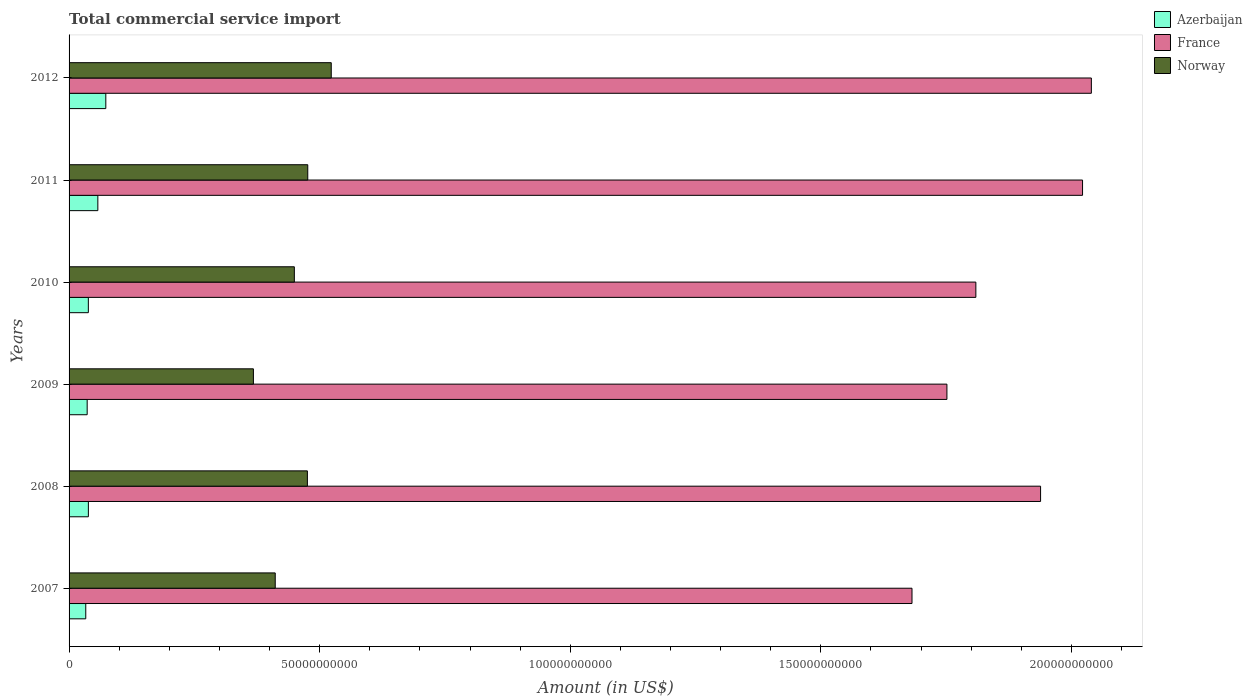How many different coloured bars are there?
Your answer should be compact. 3. Are the number of bars per tick equal to the number of legend labels?
Your response must be concise. Yes. Are the number of bars on each tick of the Y-axis equal?
Give a very brief answer. Yes. How many bars are there on the 6th tick from the bottom?
Your answer should be compact. 3. What is the label of the 4th group of bars from the top?
Provide a succinct answer. 2009. What is the total commercial service import in Azerbaijan in 2010?
Offer a terse response. 3.85e+09. Across all years, what is the maximum total commercial service import in Azerbaijan?
Offer a very short reply. 7.33e+09. Across all years, what is the minimum total commercial service import in Azerbaijan?
Your response must be concise. 3.33e+09. In which year was the total commercial service import in Norway maximum?
Offer a terse response. 2012. What is the total total commercial service import in Norway in the graph?
Offer a terse response. 2.70e+11. What is the difference between the total commercial service import in France in 2009 and that in 2010?
Your answer should be very brief. -5.77e+09. What is the difference between the total commercial service import in France in 2010 and the total commercial service import in Norway in 2012?
Provide a short and direct response. 1.29e+11. What is the average total commercial service import in Norway per year?
Provide a short and direct response. 4.51e+1. In the year 2007, what is the difference between the total commercial service import in France and total commercial service import in Norway?
Offer a very short reply. 1.27e+11. In how many years, is the total commercial service import in Azerbaijan greater than 110000000000 US$?
Offer a very short reply. 0. What is the ratio of the total commercial service import in France in 2008 to that in 2012?
Offer a very short reply. 0.95. Is the difference between the total commercial service import in France in 2009 and 2010 greater than the difference between the total commercial service import in Norway in 2009 and 2010?
Give a very brief answer. Yes. What is the difference between the highest and the second highest total commercial service import in Norway?
Offer a very short reply. 4.69e+09. What is the difference between the highest and the lowest total commercial service import in France?
Ensure brevity in your answer.  3.58e+1. Is the sum of the total commercial service import in Azerbaijan in 2010 and 2012 greater than the maximum total commercial service import in Norway across all years?
Give a very brief answer. No. What does the 1st bar from the bottom in 2008 represents?
Your response must be concise. Azerbaijan. How many bars are there?
Ensure brevity in your answer.  18. How many years are there in the graph?
Make the answer very short. 6. What is the difference between two consecutive major ticks on the X-axis?
Ensure brevity in your answer.  5.00e+1. Are the values on the major ticks of X-axis written in scientific E-notation?
Keep it short and to the point. No. Does the graph contain grids?
Offer a very short reply. No. Where does the legend appear in the graph?
Make the answer very short. Top right. How are the legend labels stacked?
Give a very brief answer. Vertical. What is the title of the graph?
Provide a short and direct response. Total commercial service import. Does "Philippines" appear as one of the legend labels in the graph?
Offer a very short reply. No. What is the label or title of the Y-axis?
Offer a terse response. Years. What is the Amount (in US$) in Azerbaijan in 2007?
Ensure brevity in your answer.  3.33e+09. What is the Amount (in US$) of France in 2007?
Offer a terse response. 1.68e+11. What is the Amount (in US$) in Norway in 2007?
Make the answer very short. 4.11e+1. What is the Amount (in US$) in Azerbaijan in 2008?
Your response must be concise. 3.85e+09. What is the Amount (in US$) in France in 2008?
Keep it short and to the point. 1.94e+11. What is the Amount (in US$) in Norway in 2008?
Your answer should be very brief. 4.76e+1. What is the Amount (in US$) in Azerbaijan in 2009?
Offer a terse response. 3.61e+09. What is the Amount (in US$) in France in 2009?
Offer a terse response. 1.75e+11. What is the Amount (in US$) in Norway in 2009?
Give a very brief answer. 3.68e+1. What is the Amount (in US$) of Azerbaijan in 2010?
Give a very brief answer. 3.85e+09. What is the Amount (in US$) in France in 2010?
Your answer should be compact. 1.81e+11. What is the Amount (in US$) of Norway in 2010?
Offer a terse response. 4.49e+1. What is the Amount (in US$) of Azerbaijan in 2011?
Ensure brevity in your answer.  5.74e+09. What is the Amount (in US$) in France in 2011?
Offer a very short reply. 2.02e+11. What is the Amount (in US$) of Norway in 2011?
Keep it short and to the point. 4.76e+1. What is the Amount (in US$) of Azerbaijan in 2012?
Your response must be concise. 7.33e+09. What is the Amount (in US$) in France in 2012?
Ensure brevity in your answer.  2.04e+11. What is the Amount (in US$) in Norway in 2012?
Your answer should be compact. 5.23e+1. Across all years, what is the maximum Amount (in US$) of Azerbaijan?
Your answer should be very brief. 7.33e+09. Across all years, what is the maximum Amount (in US$) in France?
Offer a very short reply. 2.04e+11. Across all years, what is the maximum Amount (in US$) in Norway?
Give a very brief answer. 5.23e+1. Across all years, what is the minimum Amount (in US$) in Azerbaijan?
Provide a short and direct response. 3.33e+09. Across all years, what is the minimum Amount (in US$) in France?
Make the answer very short. 1.68e+11. Across all years, what is the minimum Amount (in US$) of Norway?
Offer a very short reply. 3.68e+1. What is the total Amount (in US$) of Azerbaijan in the graph?
Provide a short and direct response. 2.77e+1. What is the total Amount (in US$) of France in the graph?
Provide a succinct answer. 1.12e+12. What is the total Amount (in US$) in Norway in the graph?
Provide a short and direct response. 2.70e+11. What is the difference between the Amount (in US$) of Azerbaijan in 2007 and that in 2008?
Ensure brevity in your answer.  -5.21e+08. What is the difference between the Amount (in US$) of France in 2007 and that in 2008?
Ensure brevity in your answer.  -2.57e+1. What is the difference between the Amount (in US$) in Norway in 2007 and that in 2008?
Give a very brief answer. -6.42e+09. What is the difference between the Amount (in US$) of Azerbaijan in 2007 and that in 2009?
Ensure brevity in your answer.  -2.82e+08. What is the difference between the Amount (in US$) in France in 2007 and that in 2009?
Your answer should be compact. -6.97e+09. What is the difference between the Amount (in US$) in Norway in 2007 and that in 2009?
Your answer should be compact. 4.35e+09. What is the difference between the Amount (in US$) of Azerbaijan in 2007 and that in 2010?
Ensure brevity in your answer.  -5.14e+08. What is the difference between the Amount (in US$) in France in 2007 and that in 2010?
Your answer should be very brief. -1.27e+1. What is the difference between the Amount (in US$) of Norway in 2007 and that in 2010?
Make the answer very short. -3.82e+09. What is the difference between the Amount (in US$) of Azerbaijan in 2007 and that in 2011?
Keep it short and to the point. -2.41e+09. What is the difference between the Amount (in US$) in France in 2007 and that in 2011?
Your answer should be compact. -3.40e+1. What is the difference between the Amount (in US$) of Norway in 2007 and that in 2011?
Offer a terse response. -6.49e+09. What is the difference between the Amount (in US$) of Azerbaijan in 2007 and that in 2012?
Offer a very short reply. -4.00e+09. What is the difference between the Amount (in US$) of France in 2007 and that in 2012?
Your response must be concise. -3.58e+1. What is the difference between the Amount (in US$) of Norway in 2007 and that in 2012?
Provide a short and direct response. -1.12e+1. What is the difference between the Amount (in US$) in Azerbaijan in 2008 and that in 2009?
Your answer should be very brief. 2.40e+08. What is the difference between the Amount (in US$) in France in 2008 and that in 2009?
Make the answer very short. 1.87e+1. What is the difference between the Amount (in US$) in Norway in 2008 and that in 2009?
Provide a succinct answer. 1.08e+1. What is the difference between the Amount (in US$) in Azerbaijan in 2008 and that in 2010?
Your answer should be compact. 6.83e+06. What is the difference between the Amount (in US$) in France in 2008 and that in 2010?
Offer a terse response. 1.29e+1. What is the difference between the Amount (in US$) of Norway in 2008 and that in 2010?
Provide a short and direct response. 2.60e+09. What is the difference between the Amount (in US$) in Azerbaijan in 2008 and that in 2011?
Ensure brevity in your answer.  -1.89e+09. What is the difference between the Amount (in US$) in France in 2008 and that in 2011?
Give a very brief answer. -8.37e+09. What is the difference between the Amount (in US$) in Norway in 2008 and that in 2011?
Offer a very short reply. -7.38e+07. What is the difference between the Amount (in US$) in Azerbaijan in 2008 and that in 2012?
Your answer should be very brief. -3.48e+09. What is the difference between the Amount (in US$) in France in 2008 and that in 2012?
Offer a terse response. -1.01e+1. What is the difference between the Amount (in US$) of Norway in 2008 and that in 2012?
Your answer should be compact. -4.76e+09. What is the difference between the Amount (in US$) in Azerbaijan in 2009 and that in 2010?
Make the answer very short. -2.33e+08. What is the difference between the Amount (in US$) in France in 2009 and that in 2010?
Offer a very short reply. -5.77e+09. What is the difference between the Amount (in US$) of Norway in 2009 and that in 2010?
Your answer should be compact. -8.17e+09. What is the difference between the Amount (in US$) of Azerbaijan in 2009 and that in 2011?
Give a very brief answer. -2.13e+09. What is the difference between the Amount (in US$) in France in 2009 and that in 2011?
Offer a very short reply. -2.71e+1. What is the difference between the Amount (in US$) of Norway in 2009 and that in 2011?
Your answer should be compact. -1.08e+1. What is the difference between the Amount (in US$) in Azerbaijan in 2009 and that in 2012?
Your response must be concise. -3.72e+09. What is the difference between the Amount (in US$) in France in 2009 and that in 2012?
Keep it short and to the point. -2.88e+1. What is the difference between the Amount (in US$) of Norway in 2009 and that in 2012?
Your answer should be very brief. -1.55e+1. What is the difference between the Amount (in US$) of Azerbaijan in 2010 and that in 2011?
Offer a very short reply. -1.90e+09. What is the difference between the Amount (in US$) of France in 2010 and that in 2011?
Provide a short and direct response. -2.13e+1. What is the difference between the Amount (in US$) of Norway in 2010 and that in 2011?
Ensure brevity in your answer.  -2.68e+09. What is the difference between the Amount (in US$) in Azerbaijan in 2010 and that in 2012?
Your answer should be compact. -3.48e+09. What is the difference between the Amount (in US$) in France in 2010 and that in 2012?
Offer a terse response. -2.30e+1. What is the difference between the Amount (in US$) in Norway in 2010 and that in 2012?
Keep it short and to the point. -7.36e+09. What is the difference between the Amount (in US$) in Azerbaijan in 2011 and that in 2012?
Offer a terse response. -1.59e+09. What is the difference between the Amount (in US$) in France in 2011 and that in 2012?
Ensure brevity in your answer.  -1.76e+09. What is the difference between the Amount (in US$) in Norway in 2011 and that in 2012?
Offer a terse response. -4.69e+09. What is the difference between the Amount (in US$) in Azerbaijan in 2007 and the Amount (in US$) in France in 2008?
Make the answer very short. -1.91e+11. What is the difference between the Amount (in US$) of Azerbaijan in 2007 and the Amount (in US$) of Norway in 2008?
Ensure brevity in your answer.  -4.42e+1. What is the difference between the Amount (in US$) in France in 2007 and the Amount (in US$) in Norway in 2008?
Your answer should be very brief. 1.21e+11. What is the difference between the Amount (in US$) in Azerbaijan in 2007 and the Amount (in US$) in France in 2009?
Give a very brief answer. -1.72e+11. What is the difference between the Amount (in US$) in Azerbaijan in 2007 and the Amount (in US$) in Norway in 2009?
Offer a very short reply. -3.34e+1. What is the difference between the Amount (in US$) in France in 2007 and the Amount (in US$) in Norway in 2009?
Make the answer very short. 1.31e+11. What is the difference between the Amount (in US$) in Azerbaijan in 2007 and the Amount (in US$) in France in 2010?
Keep it short and to the point. -1.78e+11. What is the difference between the Amount (in US$) of Azerbaijan in 2007 and the Amount (in US$) of Norway in 2010?
Provide a short and direct response. -4.16e+1. What is the difference between the Amount (in US$) of France in 2007 and the Amount (in US$) of Norway in 2010?
Your answer should be very brief. 1.23e+11. What is the difference between the Amount (in US$) in Azerbaijan in 2007 and the Amount (in US$) in France in 2011?
Provide a succinct answer. -1.99e+11. What is the difference between the Amount (in US$) of Azerbaijan in 2007 and the Amount (in US$) of Norway in 2011?
Ensure brevity in your answer.  -4.43e+1. What is the difference between the Amount (in US$) of France in 2007 and the Amount (in US$) of Norway in 2011?
Offer a terse response. 1.21e+11. What is the difference between the Amount (in US$) in Azerbaijan in 2007 and the Amount (in US$) in France in 2012?
Provide a short and direct response. -2.01e+11. What is the difference between the Amount (in US$) in Azerbaijan in 2007 and the Amount (in US$) in Norway in 2012?
Offer a terse response. -4.90e+1. What is the difference between the Amount (in US$) in France in 2007 and the Amount (in US$) in Norway in 2012?
Offer a very short reply. 1.16e+11. What is the difference between the Amount (in US$) in Azerbaijan in 2008 and the Amount (in US$) in France in 2009?
Your answer should be very brief. -1.71e+11. What is the difference between the Amount (in US$) in Azerbaijan in 2008 and the Amount (in US$) in Norway in 2009?
Offer a very short reply. -3.29e+1. What is the difference between the Amount (in US$) in France in 2008 and the Amount (in US$) in Norway in 2009?
Keep it short and to the point. 1.57e+11. What is the difference between the Amount (in US$) of Azerbaijan in 2008 and the Amount (in US$) of France in 2010?
Your response must be concise. -1.77e+11. What is the difference between the Amount (in US$) of Azerbaijan in 2008 and the Amount (in US$) of Norway in 2010?
Offer a very short reply. -4.11e+1. What is the difference between the Amount (in US$) of France in 2008 and the Amount (in US$) of Norway in 2010?
Offer a very short reply. 1.49e+11. What is the difference between the Amount (in US$) in Azerbaijan in 2008 and the Amount (in US$) in France in 2011?
Make the answer very short. -1.98e+11. What is the difference between the Amount (in US$) of Azerbaijan in 2008 and the Amount (in US$) of Norway in 2011?
Your response must be concise. -4.38e+1. What is the difference between the Amount (in US$) in France in 2008 and the Amount (in US$) in Norway in 2011?
Your answer should be very brief. 1.46e+11. What is the difference between the Amount (in US$) in Azerbaijan in 2008 and the Amount (in US$) in France in 2012?
Ensure brevity in your answer.  -2.00e+11. What is the difference between the Amount (in US$) of Azerbaijan in 2008 and the Amount (in US$) of Norway in 2012?
Ensure brevity in your answer.  -4.85e+1. What is the difference between the Amount (in US$) of France in 2008 and the Amount (in US$) of Norway in 2012?
Keep it short and to the point. 1.42e+11. What is the difference between the Amount (in US$) in Azerbaijan in 2009 and the Amount (in US$) in France in 2010?
Your response must be concise. -1.77e+11. What is the difference between the Amount (in US$) in Azerbaijan in 2009 and the Amount (in US$) in Norway in 2010?
Keep it short and to the point. -4.13e+1. What is the difference between the Amount (in US$) of France in 2009 and the Amount (in US$) of Norway in 2010?
Your response must be concise. 1.30e+11. What is the difference between the Amount (in US$) in Azerbaijan in 2009 and the Amount (in US$) in France in 2011?
Make the answer very short. -1.99e+11. What is the difference between the Amount (in US$) of Azerbaijan in 2009 and the Amount (in US$) of Norway in 2011?
Your response must be concise. -4.40e+1. What is the difference between the Amount (in US$) of France in 2009 and the Amount (in US$) of Norway in 2011?
Your answer should be very brief. 1.28e+11. What is the difference between the Amount (in US$) in Azerbaijan in 2009 and the Amount (in US$) in France in 2012?
Your answer should be compact. -2.00e+11. What is the difference between the Amount (in US$) in Azerbaijan in 2009 and the Amount (in US$) in Norway in 2012?
Keep it short and to the point. -4.87e+1. What is the difference between the Amount (in US$) of France in 2009 and the Amount (in US$) of Norway in 2012?
Make the answer very short. 1.23e+11. What is the difference between the Amount (in US$) of Azerbaijan in 2010 and the Amount (in US$) of France in 2011?
Ensure brevity in your answer.  -1.98e+11. What is the difference between the Amount (in US$) in Azerbaijan in 2010 and the Amount (in US$) in Norway in 2011?
Give a very brief answer. -4.38e+1. What is the difference between the Amount (in US$) in France in 2010 and the Amount (in US$) in Norway in 2011?
Provide a succinct answer. 1.33e+11. What is the difference between the Amount (in US$) of Azerbaijan in 2010 and the Amount (in US$) of France in 2012?
Provide a short and direct response. -2.00e+11. What is the difference between the Amount (in US$) of Azerbaijan in 2010 and the Amount (in US$) of Norway in 2012?
Keep it short and to the point. -4.85e+1. What is the difference between the Amount (in US$) of France in 2010 and the Amount (in US$) of Norway in 2012?
Give a very brief answer. 1.29e+11. What is the difference between the Amount (in US$) in Azerbaijan in 2011 and the Amount (in US$) in France in 2012?
Provide a short and direct response. -1.98e+11. What is the difference between the Amount (in US$) of Azerbaijan in 2011 and the Amount (in US$) of Norway in 2012?
Keep it short and to the point. -4.66e+1. What is the difference between the Amount (in US$) in France in 2011 and the Amount (in US$) in Norway in 2012?
Your answer should be compact. 1.50e+11. What is the average Amount (in US$) in Azerbaijan per year?
Keep it short and to the point. 4.62e+09. What is the average Amount (in US$) in France per year?
Your response must be concise. 1.87e+11. What is the average Amount (in US$) in Norway per year?
Give a very brief answer. 4.51e+1. In the year 2007, what is the difference between the Amount (in US$) of Azerbaijan and Amount (in US$) of France?
Keep it short and to the point. -1.65e+11. In the year 2007, what is the difference between the Amount (in US$) of Azerbaijan and Amount (in US$) of Norway?
Provide a succinct answer. -3.78e+1. In the year 2007, what is the difference between the Amount (in US$) of France and Amount (in US$) of Norway?
Give a very brief answer. 1.27e+11. In the year 2008, what is the difference between the Amount (in US$) in Azerbaijan and Amount (in US$) in France?
Your response must be concise. -1.90e+11. In the year 2008, what is the difference between the Amount (in US$) of Azerbaijan and Amount (in US$) of Norway?
Keep it short and to the point. -4.37e+1. In the year 2008, what is the difference between the Amount (in US$) in France and Amount (in US$) in Norway?
Keep it short and to the point. 1.46e+11. In the year 2009, what is the difference between the Amount (in US$) in Azerbaijan and Amount (in US$) in France?
Offer a terse response. -1.72e+11. In the year 2009, what is the difference between the Amount (in US$) of Azerbaijan and Amount (in US$) of Norway?
Make the answer very short. -3.32e+1. In the year 2009, what is the difference between the Amount (in US$) of France and Amount (in US$) of Norway?
Your answer should be very brief. 1.38e+11. In the year 2010, what is the difference between the Amount (in US$) in Azerbaijan and Amount (in US$) in France?
Ensure brevity in your answer.  -1.77e+11. In the year 2010, what is the difference between the Amount (in US$) of Azerbaijan and Amount (in US$) of Norway?
Provide a succinct answer. -4.11e+1. In the year 2010, what is the difference between the Amount (in US$) of France and Amount (in US$) of Norway?
Your response must be concise. 1.36e+11. In the year 2011, what is the difference between the Amount (in US$) in Azerbaijan and Amount (in US$) in France?
Make the answer very short. -1.96e+11. In the year 2011, what is the difference between the Amount (in US$) of Azerbaijan and Amount (in US$) of Norway?
Provide a short and direct response. -4.19e+1. In the year 2011, what is the difference between the Amount (in US$) of France and Amount (in US$) of Norway?
Your answer should be compact. 1.55e+11. In the year 2012, what is the difference between the Amount (in US$) in Azerbaijan and Amount (in US$) in France?
Provide a short and direct response. -1.97e+11. In the year 2012, what is the difference between the Amount (in US$) of Azerbaijan and Amount (in US$) of Norway?
Provide a succinct answer. -4.50e+1. In the year 2012, what is the difference between the Amount (in US$) of France and Amount (in US$) of Norway?
Provide a succinct answer. 1.52e+11. What is the ratio of the Amount (in US$) of Azerbaijan in 2007 to that in 2008?
Make the answer very short. 0.86. What is the ratio of the Amount (in US$) of France in 2007 to that in 2008?
Offer a very short reply. 0.87. What is the ratio of the Amount (in US$) in Norway in 2007 to that in 2008?
Your answer should be compact. 0.86. What is the ratio of the Amount (in US$) of Azerbaijan in 2007 to that in 2009?
Provide a succinct answer. 0.92. What is the ratio of the Amount (in US$) in France in 2007 to that in 2009?
Provide a succinct answer. 0.96. What is the ratio of the Amount (in US$) of Norway in 2007 to that in 2009?
Provide a short and direct response. 1.12. What is the ratio of the Amount (in US$) in Azerbaijan in 2007 to that in 2010?
Provide a short and direct response. 0.87. What is the ratio of the Amount (in US$) in France in 2007 to that in 2010?
Give a very brief answer. 0.93. What is the ratio of the Amount (in US$) in Norway in 2007 to that in 2010?
Offer a terse response. 0.92. What is the ratio of the Amount (in US$) in Azerbaijan in 2007 to that in 2011?
Offer a very short reply. 0.58. What is the ratio of the Amount (in US$) of France in 2007 to that in 2011?
Offer a terse response. 0.83. What is the ratio of the Amount (in US$) in Norway in 2007 to that in 2011?
Give a very brief answer. 0.86. What is the ratio of the Amount (in US$) in Azerbaijan in 2007 to that in 2012?
Offer a very short reply. 0.45. What is the ratio of the Amount (in US$) in France in 2007 to that in 2012?
Your response must be concise. 0.82. What is the ratio of the Amount (in US$) of Norway in 2007 to that in 2012?
Provide a short and direct response. 0.79. What is the ratio of the Amount (in US$) of Azerbaijan in 2008 to that in 2009?
Offer a very short reply. 1.07. What is the ratio of the Amount (in US$) of France in 2008 to that in 2009?
Your answer should be compact. 1.11. What is the ratio of the Amount (in US$) of Norway in 2008 to that in 2009?
Offer a terse response. 1.29. What is the ratio of the Amount (in US$) in France in 2008 to that in 2010?
Your answer should be compact. 1.07. What is the ratio of the Amount (in US$) of Norway in 2008 to that in 2010?
Make the answer very short. 1.06. What is the ratio of the Amount (in US$) of Azerbaijan in 2008 to that in 2011?
Provide a short and direct response. 0.67. What is the ratio of the Amount (in US$) in France in 2008 to that in 2011?
Ensure brevity in your answer.  0.96. What is the ratio of the Amount (in US$) of Norway in 2008 to that in 2011?
Your answer should be very brief. 1. What is the ratio of the Amount (in US$) of Azerbaijan in 2008 to that in 2012?
Your answer should be compact. 0.53. What is the ratio of the Amount (in US$) of France in 2008 to that in 2012?
Offer a terse response. 0.95. What is the ratio of the Amount (in US$) of Norway in 2008 to that in 2012?
Your answer should be compact. 0.91. What is the ratio of the Amount (in US$) of Azerbaijan in 2009 to that in 2010?
Offer a very short reply. 0.94. What is the ratio of the Amount (in US$) in France in 2009 to that in 2010?
Your answer should be compact. 0.97. What is the ratio of the Amount (in US$) in Norway in 2009 to that in 2010?
Make the answer very short. 0.82. What is the ratio of the Amount (in US$) of Azerbaijan in 2009 to that in 2011?
Your answer should be compact. 0.63. What is the ratio of the Amount (in US$) in France in 2009 to that in 2011?
Make the answer very short. 0.87. What is the ratio of the Amount (in US$) of Norway in 2009 to that in 2011?
Keep it short and to the point. 0.77. What is the ratio of the Amount (in US$) of Azerbaijan in 2009 to that in 2012?
Your answer should be compact. 0.49. What is the ratio of the Amount (in US$) of France in 2009 to that in 2012?
Your answer should be compact. 0.86. What is the ratio of the Amount (in US$) in Norway in 2009 to that in 2012?
Provide a succinct answer. 0.7. What is the ratio of the Amount (in US$) of Azerbaijan in 2010 to that in 2011?
Give a very brief answer. 0.67. What is the ratio of the Amount (in US$) of France in 2010 to that in 2011?
Provide a succinct answer. 0.89. What is the ratio of the Amount (in US$) of Norway in 2010 to that in 2011?
Offer a very short reply. 0.94. What is the ratio of the Amount (in US$) in Azerbaijan in 2010 to that in 2012?
Provide a succinct answer. 0.52. What is the ratio of the Amount (in US$) of France in 2010 to that in 2012?
Your answer should be very brief. 0.89. What is the ratio of the Amount (in US$) in Norway in 2010 to that in 2012?
Provide a short and direct response. 0.86. What is the ratio of the Amount (in US$) of Azerbaijan in 2011 to that in 2012?
Provide a short and direct response. 0.78. What is the ratio of the Amount (in US$) of France in 2011 to that in 2012?
Your answer should be compact. 0.99. What is the ratio of the Amount (in US$) of Norway in 2011 to that in 2012?
Make the answer very short. 0.91. What is the difference between the highest and the second highest Amount (in US$) of Azerbaijan?
Offer a very short reply. 1.59e+09. What is the difference between the highest and the second highest Amount (in US$) of France?
Offer a very short reply. 1.76e+09. What is the difference between the highest and the second highest Amount (in US$) of Norway?
Your answer should be very brief. 4.69e+09. What is the difference between the highest and the lowest Amount (in US$) of Azerbaijan?
Ensure brevity in your answer.  4.00e+09. What is the difference between the highest and the lowest Amount (in US$) of France?
Ensure brevity in your answer.  3.58e+1. What is the difference between the highest and the lowest Amount (in US$) of Norway?
Your answer should be very brief. 1.55e+1. 